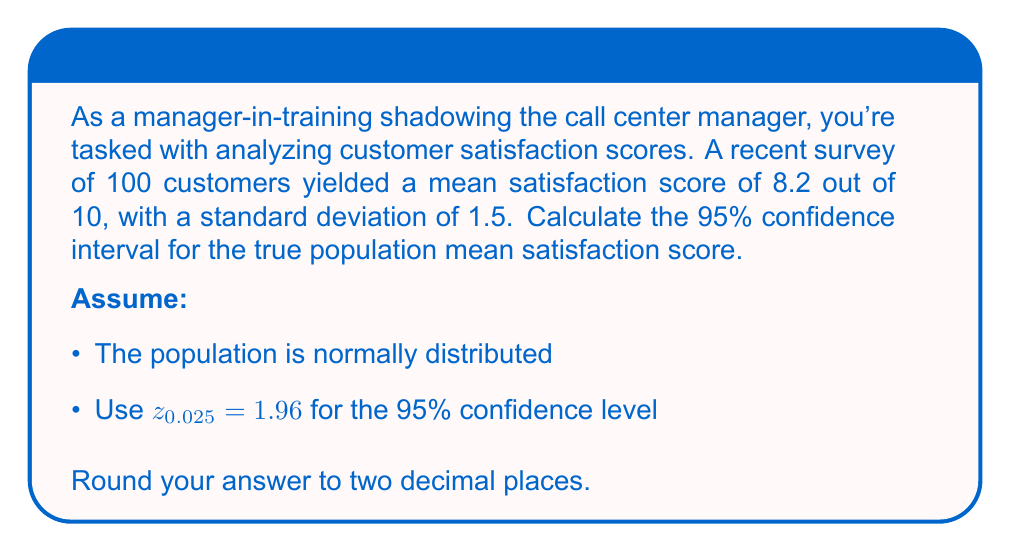Solve this math problem. To calculate the confidence interval, we'll use the formula:

$$ \text{CI} = \bar{x} \pm z_{\alpha/2} \cdot \frac{\sigma}{\sqrt{n}} $$

Where:
$\bar{x}$ = sample mean = 8.2
$z_{\alpha/2}$ = z-score for 95% confidence level = 1.96
$\sigma$ = standard deviation = 1.5
$n$ = sample size = 100

Step 1: Calculate the standard error of the mean (SEM):
$$ \text{SEM} = \frac{\sigma}{\sqrt{n}} = \frac{1.5}{\sqrt{100}} = 0.15 $$

Step 2: Calculate the margin of error:
$$ \text{Margin of Error} = z_{\alpha/2} \cdot \text{SEM} = 1.96 \cdot 0.15 = 0.294 $$

Step 3: Calculate the lower and upper bounds of the confidence interval:
$$ \text{Lower bound} = 8.2 - 0.294 = 7.906 $$
$$ \text{Upper bound} = 8.2 + 0.294 = 8.494 $$

Step 4: Round to two decimal places:
$$ \text{CI} = (7.91, 8.49) $$
Answer: (7.91, 8.49) 